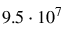Convert formula to latex. <formula><loc_0><loc_0><loc_500><loc_500>9 . 5 \cdot 1 0 ^ { 7 }</formula> 